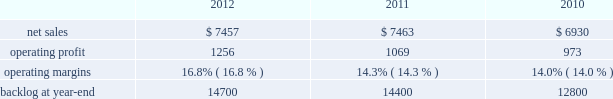2011 compared to 2010 is&gs 2019 net sales for 2011 decreased $ 540 million , or 5% ( 5 % ) , compared to 2010 .
The decrease primarily was attributable to lower volume of approximately $ 665 million due to the absence of the dris program that supported the 2010 u.s .
Census and a decline in activities on the jtrs program .
This decrease partially was offset by increased net sales on numerous programs .
Is&gs 2019 operating profit for 2011 increased $ 60 million , or 7% ( 7 % ) , compared to 2010 .
Operating profit increased approximately $ 180 million due to volume and the retirement of risks in 2011 and the absence of reserves recognized in 2010 on numerous programs ( including among others , odin ( about $ 60 million ) and twic and automated flight service station programs ) .
The increases in operating profit partially were offset by the absence of the dris program and a decline in activities on the jtrs program of about $ 120 million .
Adjustments not related to volume , including net profit rate adjustments described above , were approximately $ 130 million higher in 2011 compared to 2010 .
Backlog backlog decreased in 2012 compared to 2011 primarily due to the substantial completion of various programs in 2011 ( primarily odin , u.k .
Census , and jtrs ) .
The decrease in backlog during 2011 compared to 2010 mainly was due to declining activities on the jtrs program and several other smaller programs .
Trends we expect is&gs 2019 net sales to decline in 2013 in the mid single digit percentage range as compared to 2012 primarily due to the continued downturn in federal information technology budgets .
Operating profit is expected to decline in 2013 in the mid single digit percentage range consistent with the expected decline in net sales , resulting in margins that are comparable with 2012 results .
Missiles and fire control our mfc business segment provides air and missile defense systems ; tactical missiles and air-to-ground precision strike weapon systems ; fire control systems ; mission operations support , readiness , engineering support , and integration services ; logistics and other technical services ; and manned and unmanned ground vehicles .
Mfc 2019s major programs include pac-3 , thaad , multiple launch rocket system ( mlrs ) , hellfire , javelin , joint air-to-surface standoff missile ( jassm ) , apache fire control system ( apache ) , sniper ae , low altitude navigation and targeting infrared for night ( lantirn ae ) , and sof clss .
Mfc 2019s operating results included the following ( in millions ) : .
2012 compared to 2011 mfc 2019s net sales for 2012 were comparable to 2011 .
Net sales decreased approximately $ 130 million due to lower volume and risk retirements on various services programs , and about $ 60 million due to lower volume from fire control systems programs ( primarily sniper ae ; lantirn ae ; and apache ) .
The decreases largely were offset by higher net sales of approximately $ 95 million due to higher volume from tactical missile programs ( primarily javelin and hellfire ) and approximately $ 80 million for air and missile defense programs ( primarily pac-3 and thaad ) .
Mfc 2019s operating profit for 2012 increased $ 187 million , or 17% ( 17 % ) , compared to 2011 .
The increase was attributable to higher risk retirements and volume of about $ 95 million from tactical missile programs ( primarily javelin and hellfire ) ; increased risk retirements and volume of approximately $ 60 million for air and missile defense programs ( primarily thaad and pac-3 ) ; and about $ 45 million from a resolution of contractual matters .
Partially offsetting these increases was lower risk retirements and volume on various programs , including $ 25 million for services programs .
Adjustments not related to volume , including net profit booking rate adjustments and other matters described above , were approximately $ 145 million higher for 2012 compared to 2011. .
What is the growth rate in net sales for mfc in 2012? 
Computations: ((7457 - 7463) / 7463)
Answer: -0.0008. 